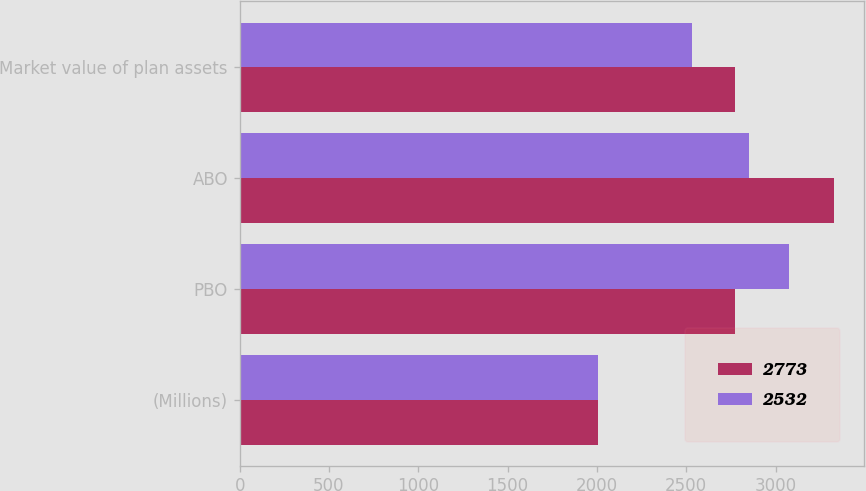Convert chart to OTSL. <chart><loc_0><loc_0><loc_500><loc_500><stacked_bar_chart><ecel><fcel>(Millions)<fcel>PBO<fcel>ABO<fcel>Market value of plan assets<nl><fcel>2773<fcel>2005<fcel>2773<fcel>3328<fcel>2773<nl><fcel>2532<fcel>2004<fcel>3074<fcel>2851<fcel>2532<nl></chart> 